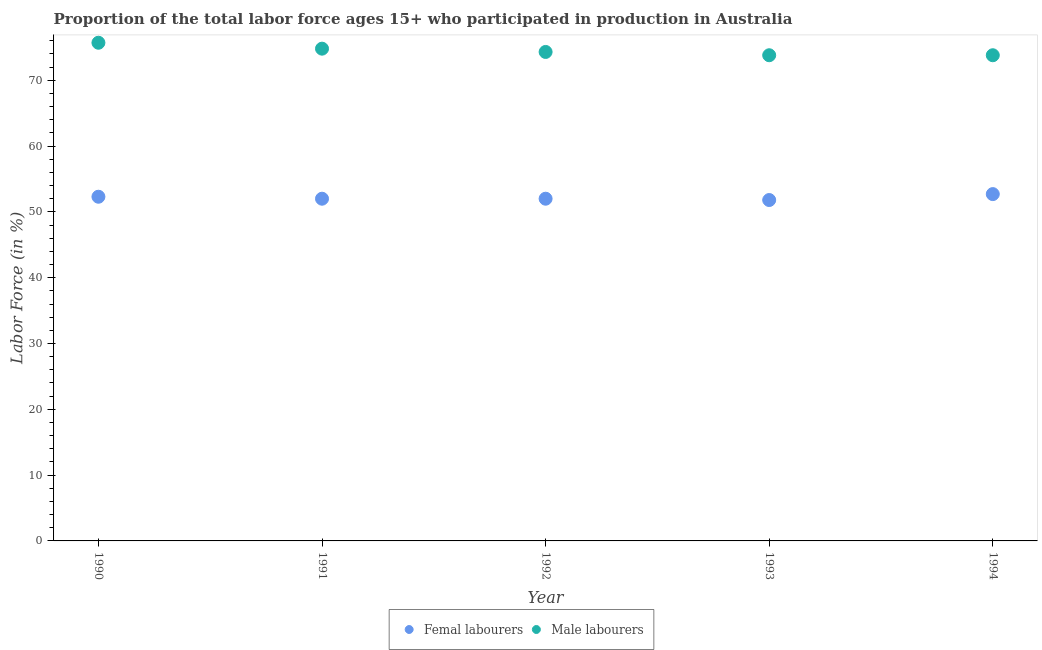Is the number of dotlines equal to the number of legend labels?
Give a very brief answer. Yes. What is the percentage of male labour force in 1991?
Your answer should be compact. 74.8. Across all years, what is the maximum percentage of male labour force?
Provide a short and direct response. 75.7. Across all years, what is the minimum percentage of male labour force?
Make the answer very short. 73.8. In which year was the percentage of male labour force maximum?
Offer a terse response. 1990. What is the total percentage of female labor force in the graph?
Your answer should be compact. 260.8. What is the difference between the percentage of male labour force in 1991 and that in 1994?
Offer a very short reply. 1. What is the difference between the percentage of female labor force in 1993 and the percentage of male labour force in 1991?
Give a very brief answer. -23. What is the average percentage of male labour force per year?
Provide a succinct answer. 74.48. In the year 1994, what is the difference between the percentage of male labour force and percentage of female labor force?
Your answer should be very brief. 21.1. What is the ratio of the percentage of female labor force in 1990 to that in 1994?
Give a very brief answer. 0.99. Is the difference between the percentage of male labour force in 1991 and 1992 greater than the difference between the percentage of female labor force in 1991 and 1992?
Make the answer very short. Yes. What is the difference between the highest and the second highest percentage of female labor force?
Provide a succinct answer. 0.4. What is the difference between the highest and the lowest percentage of male labour force?
Ensure brevity in your answer.  1.9. In how many years, is the percentage of female labor force greater than the average percentage of female labor force taken over all years?
Give a very brief answer. 2. Is the sum of the percentage of male labour force in 1991 and 1994 greater than the maximum percentage of female labor force across all years?
Your response must be concise. Yes. Is the percentage of female labor force strictly less than the percentage of male labour force over the years?
Make the answer very short. Yes. How many years are there in the graph?
Give a very brief answer. 5. What is the difference between two consecutive major ticks on the Y-axis?
Offer a terse response. 10. Are the values on the major ticks of Y-axis written in scientific E-notation?
Offer a terse response. No. Does the graph contain grids?
Provide a succinct answer. No. How many legend labels are there?
Provide a short and direct response. 2. How are the legend labels stacked?
Provide a succinct answer. Horizontal. What is the title of the graph?
Your answer should be very brief. Proportion of the total labor force ages 15+ who participated in production in Australia. Does "Attending school" appear as one of the legend labels in the graph?
Ensure brevity in your answer.  No. What is the label or title of the Y-axis?
Ensure brevity in your answer.  Labor Force (in %). What is the Labor Force (in %) in Femal labourers in 1990?
Ensure brevity in your answer.  52.3. What is the Labor Force (in %) of Male labourers in 1990?
Offer a very short reply. 75.7. What is the Labor Force (in %) in Male labourers in 1991?
Provide a short and direct response. 74.8. What is the Labor Force (in %) of Femal labourers in 1992?
Your response must be concise. 52. What is the Labor Force (in %) in Male labourers in 1992?
Keep it short and to the point. 74.3. What is the Labor Force (in %) of Femal labourers in 1993?
Your answer should be compact. 51.8. What is the Labor Force (in %) of Male labourers in 1993?
Your answer should be very brief. 73.8. What is the Labor Force (in %) of Femal labourers in 1994?
Offer a very short reply. 52.7. What is the Labor Force (in %) in Male labourers in 1994?
Offer a very short reply. 73.8. Across all years, what is the maximum Labor Force (in %) of Femal labourers?
Your answer should be compact. 52.7. Across all years, what is the maximum Labor Force (in %) in Male labourers?
Make the answer very short. 75.7. Across all years, what is the minimum Labor Force (in %) in Femal labourers?
Ensure brevity in your answer.  51.8. Across all years, what is the minimum Labor Force (in %) in Male labourers?
Make the answer very short. 73.8. What is the total Labor Force (in %) of Femal labourers in the graph?
Provide a succinct answer. 260.8. What is the total Labor Force (in %) in Male labourers in the graph?
Provide a short and direct response. 372.4. What is the difference between the Labor Force (in %) in Femal labourers in 1990 and that in 1993?
Your answer should be compact. 0.5. What is the difference between the Labor Force (in %) of Male labourers in 1990 and that in 1993?
Your response must be concise. 1.9. What is the difference between the Labor Force (in %) of Femal labourers in 1990 and that in 1994?
Your answer should be compact. -0.4. What is the difference between the Labor Force (in %) in Femal labourers in 1991 and that in 1992?
Your answer should be very brief. 0. What is the difference between the Labor Force (in %) in Femal labourers in 1991 and that in 1993?
Ensure brevity in your answer.  0.2. What is the difference between the Labor Force (in %) of Male labourers in 1991 and that in 1993?
Your answer should be compact. 1. What is the difference between the Labor Force (in %) in Femal labourers in 1991 and that in 1994?
Offer a very short reply. -0.7. What is the difference between the Labor Force (in %) of Male labourers in 1992 and that in 1993?
Offer a very short reply. 0.5. What is the difference between the Labor Force (in %) in Femal labourers in 1992 and that in 1994?
Make the answer very short. -0.7. What is the difference between the Labor Force (in %) in Femal labourers in 1993 and that in 1994?
Offer a very short reply. -0.9. What is the difference between the Labor Force (in %) of Femal labourers in 1990 and the Labor Force (in %) of Male labourers in 1991?
Make the answer very short. -22.5. What is the difference between the Labor Force (in %) of Femal labourers in 1990 and the Labor Force (in %) of Male labourers in 1993?
Ensure brevity in your answer.  -21.5. What is the difference between the Labor Force (in %) of Femal labourers in 1990 and the Labor Force (in %) of Male labourers in 1994?
Offer a terse response. -21.5. What is the difference between the Labor Force (in %) of Femal labourers in 1991 and the Labor Force (in %) of Male labourers in 1992?
Give a very brief answer. -22.3. What is the difference between the Labor Force (in %) of Femal labourers in 1991 and the Labor Force (in %) of Male labourers in 1993?
Your answer should be compact. -21.8. What is the difference between the Labor Force (in %) in Femal labourers in 1991 and the Labor Force (in %) in Male labourers in 1994?
Give a very brief answer. -21.8. What is the difference between the Labor Force (in %) in Femal labourers in 1992 and the Labor Force (in %) in Male labourers in 1993?
Give a very brief answer. -21.8. What is the difference between the Labor Force (in %) in Femal labourers in 1992 and the Labor Force (in %) in Male labourers in 1994?
Provide a short and direct response. -21.8. What is the average Labor Force (in %) of Femal labourers per year?
Ensure brevity in your answer.  52.16. What is the average Labor Force (in %) of Male labourers per year?
Make the answer very short. 74.48. In the year 1990, what is the difference between the Labor Force (in %) in Femal labourers and Labor Force (in %) in Male labourers?
Keep it short and to the point. -23.4. In the year 1991, what is the difference between the Labor Force (in %) of Femal labourers and Labor Force (in %) of Male labourers?
Give a very brief answer. -22.8. In the year 1992, what is the difference between the Labor Force (in %) of Femal labourers and Labor Force (in %) of Male labourers?
Ensure brevity in your answer.  -22.3. In the year 1994, what is the difference between the Labor Force (in %) in Femal labourers and Labor Force (in %) in Male labourers?
Provide a succinct answer. -21.1. What is the ratio of the Labor Force (in %) of Femal labourers in 1990 to that in 1992?
Provide a short and direct response. 1.01. What is the ratio of the Labor Force (in %) in Male labourers in 1990 to that in 1992?
Keep it short and to the point. 1.02. What is the ratio of the Labor Force (in %) in Femal labourers in 1990 to that in 1993?
Provide a short and direct response. 1.01. What is the ratio of the Labor Force (in %) of Male labourers in 1990 to that in 1993?
Offer a terse response. 1.03. What is the ratio of the Labor Force (in %) in Femal labourers in 1990 to that in 1994?
Ensure brevity in your answer.  0.99. What is the ratio of the Labor Force (in %) in Male labourers in 1990 to that in 1994?
Offer a very short reply. 1.03. What is the ratio of the Labor Force (in %) of Femal labourers in 1991 to that in 1992?
Offer a terse response. 1. What is the ratio of the Labor Force (in %) of Femal labourers in 1991 to that in 1993?
Your response must be concise. 1. What is the ratio of the Labor Force (in %) of Male labourers in 1991 to that in 1993?
Provide a succinct answer. 1.01. What is the ratio of the Labor Force (in %) in Femal labourers in 1991 to that in 1994?
Make the answer very short. 0.99. What is the ratio of the Labor Force (in %) of Male labourers in 1991 to that in 1994?
Offer a terse response. 1.01. What is the ratio of the Labor Force (in %) of Femal labourers in 1992 to that in 1993?
Provide a succinct answer. 1. What is the ratio of the Labor Force (in %) of Male labourers in 1992 to that in 1993?
Offer a very short reply. 1.01. What is the ratio of the Labor Force (in %) in Femal labourers in 1992 to that in 1994?
Provide a succinct answer. 0.99. What is the ratio of the Labor Force (in %) of Male labourers in 1992 to that in 1994?
Offer a very short reply. 1.01. What is the ratio of the Labor Force (in %) of Femal labourers in 1993 to that in 1994?
Keep it short and to the point. 0.98. What is the difference between the highest and the second highest Labor Force (in %) of Femal labourers?
Your answer should be compact. 0.4. What is the difference between the highest and the second highest Labor Force (in %) of Male labourers?
Ensure brevity in your answer.  0.9. What is the difference between the highest and the lowest Labor Force (in %) in Femal labourers?
Offer a very short reply. 0.9. What is the difference between the highest and the lowest Labor Force (in %) in Male labourers?
Your answer should be very brief. 1.9. 